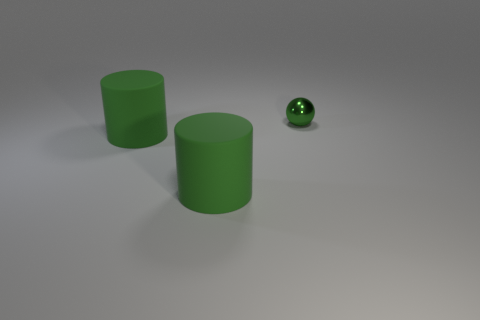Are there any other things that are made of the same material as the small object?
Provide a short and direct response. No. How many things are small green metal cubes or things that are to the left of the tiny green metallic sphere?
Provide a succinct answer. 2. How many green things are large matte cylinders or small metallic balls?
Your answer should be very brief. 3. There is a green metal thing; are there any shiny things left of it?
Make the answer very short. No. The ball is what size?
Your response must be concise. Small. What number of large objects have the same color as the small sphere?
Provide a short and direct response. 2. Is there another green thing of the same shape as the small shiny object?
Provide a short and direct response. No. Are there more spheres than green cylinders?
Provide a succinct answer. No. What number of cylinders are metallic objects or large blue objects?
Provide a short and direct response. 0. Are there fewer big yellow objects than big matte cylinders?
Offer a very short reply. Yes. 